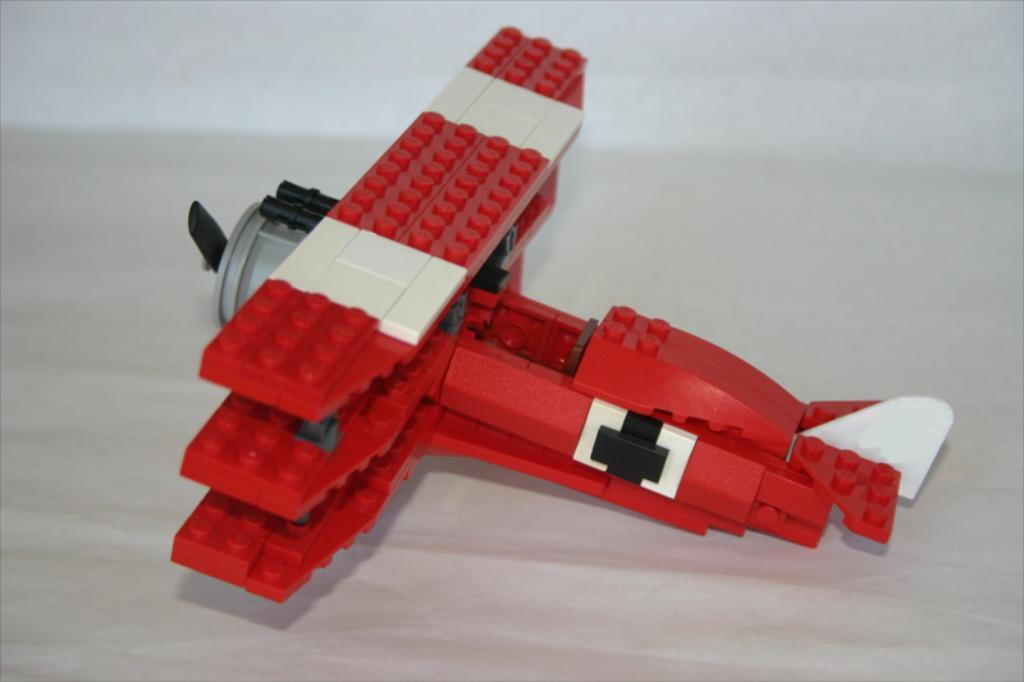What object is the main subject of the image? There is a toy aeroplane in the image. What color is the toy aeroplane? The toy aeroplane is red in color. How many ducks are visible in the image? There are no ducks present in the image. What type of line is used to draw the toy aeroplane in the image? The image is a photograph, not a drawing, so there is no line used to draw the toy aeroplane. 